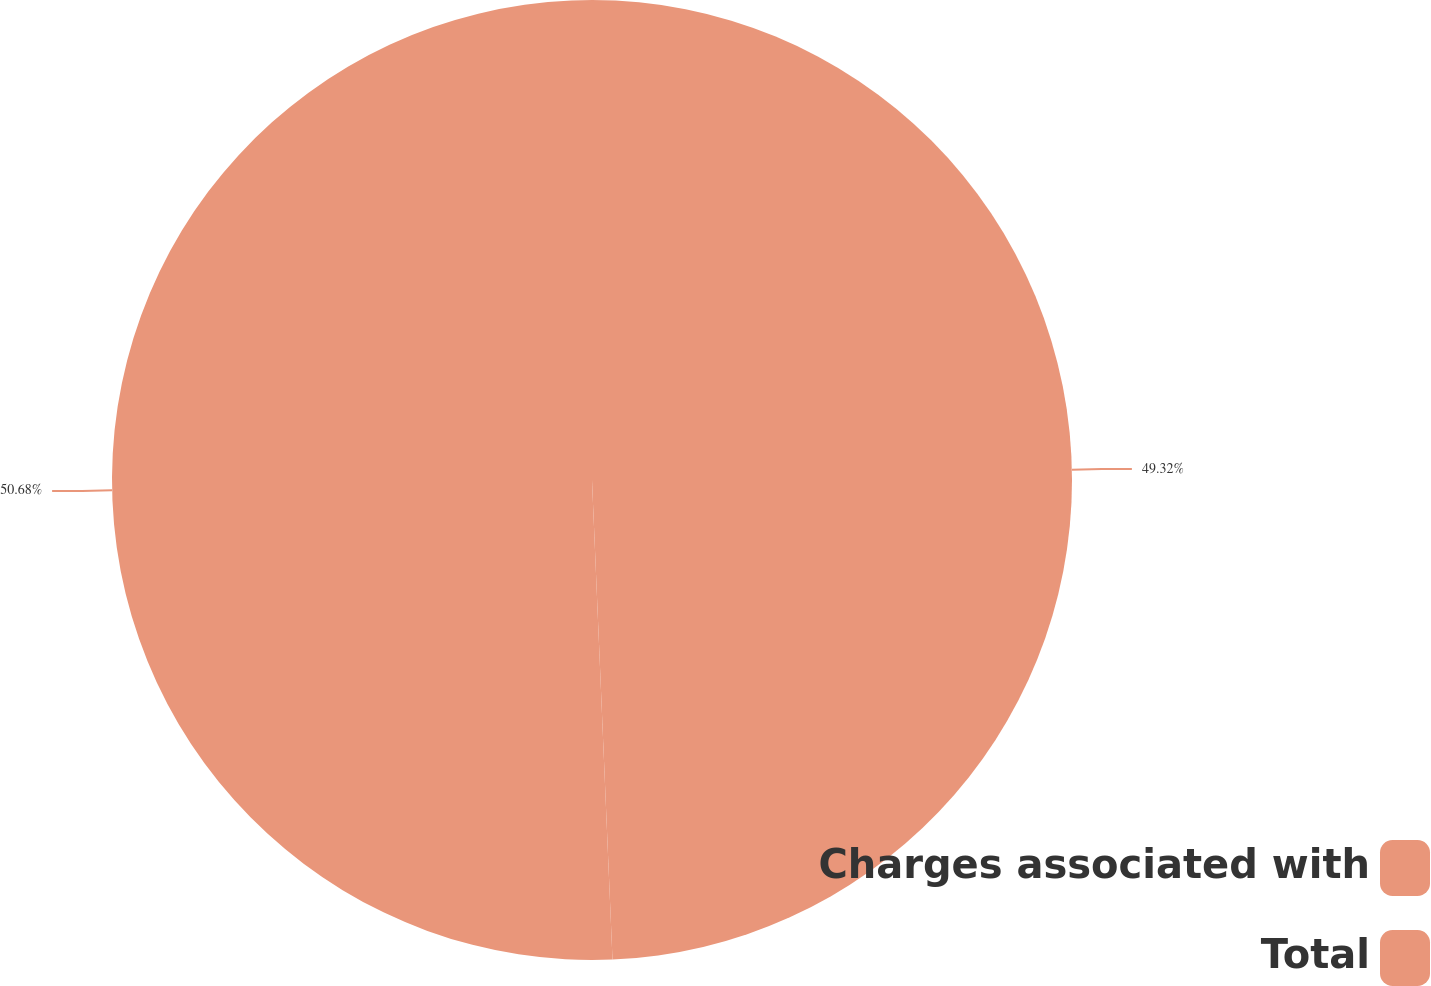Convert chart. <chart><loc_0><loc_0><loc_500><loc_500><pie_chart><fcel>Charges associated with<fcel>Total<nl><fcel>49.32%<fcel>50.68%<nl></chart> 